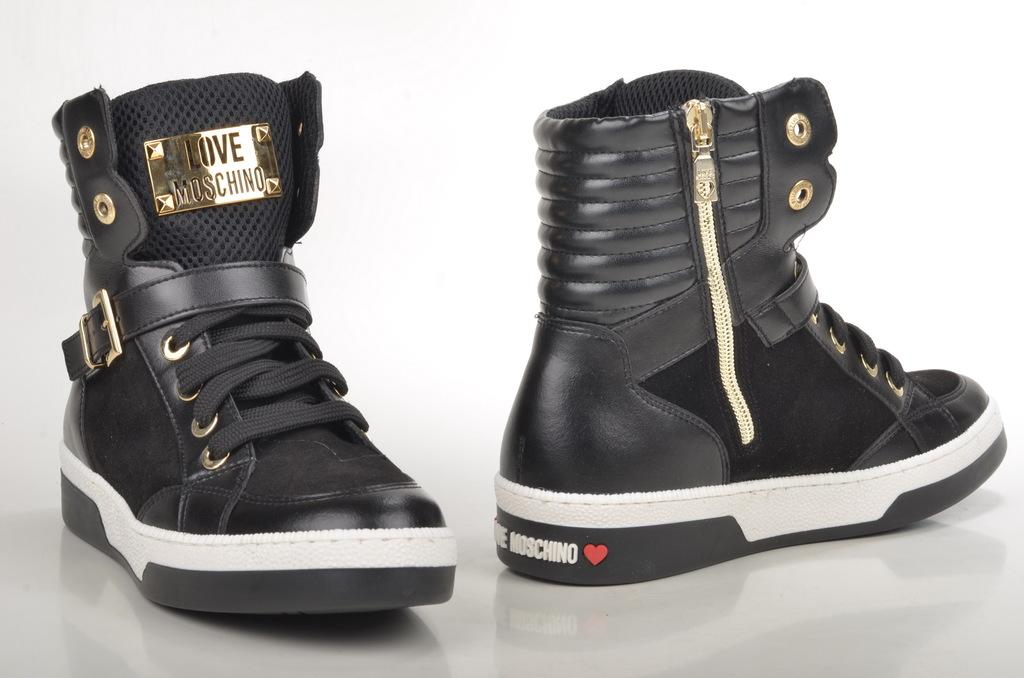What type of footwear is in the image? There is a pair of boots in the image. Where are the boots located? The boots are on the floor. What color is the background of the image? The background of the image is white. Is there any text or writing on the boots? Yes, there is text on one of the boots. What type of bag is the stranger holding in the image? There is no stranger or bag present in the image; it only features a pair of boots on the floor. 